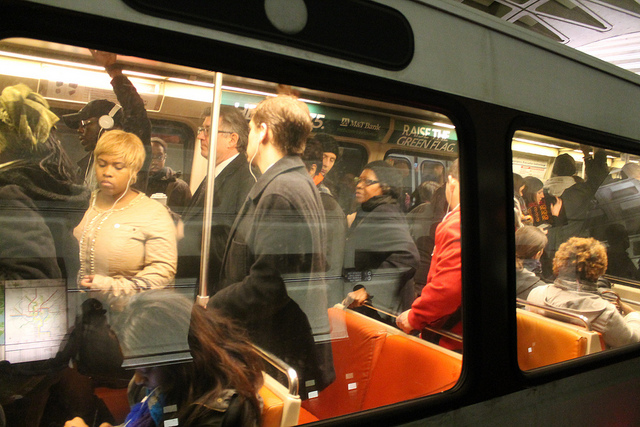Read and extract the text from this image. RAISE GREEN FLAG 